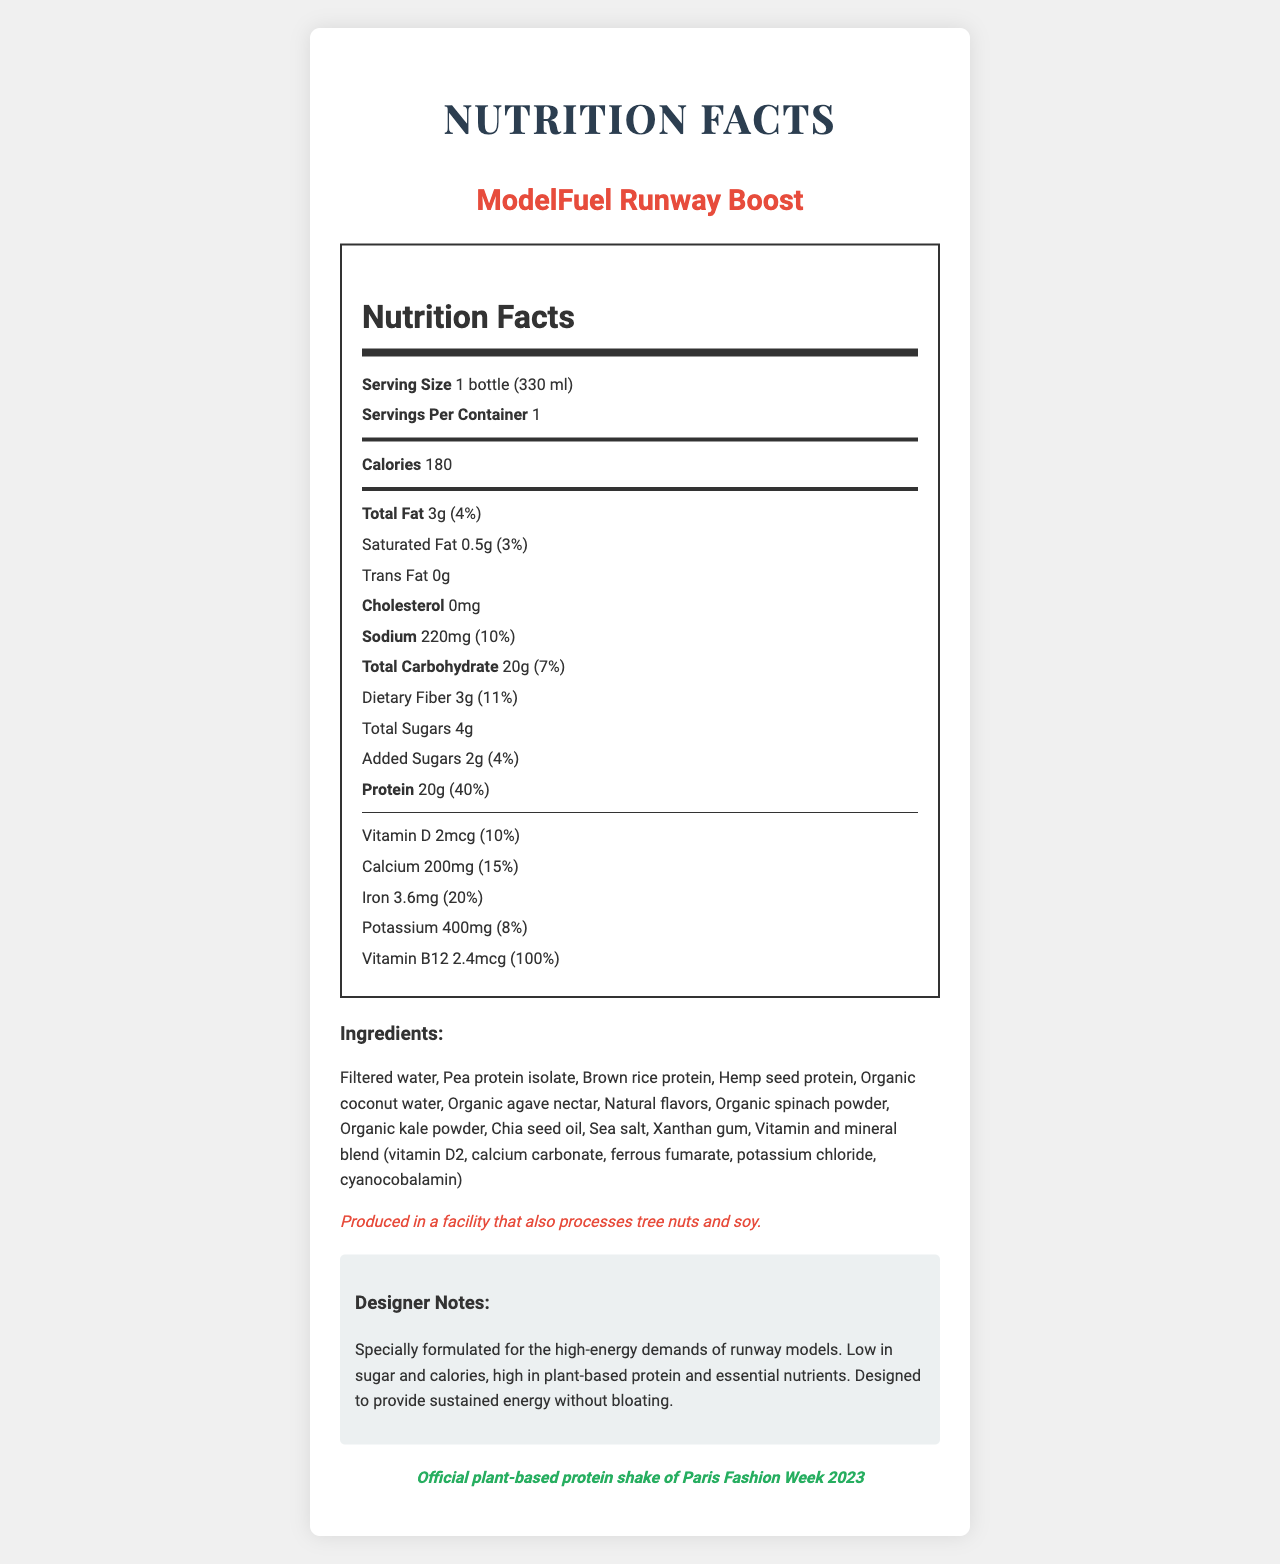how many calories are in one serving? The document lists the calorie content as 180 for one bottle, which is one serving.
Answer: 180 what is the serving size for ModelFuel Runway Boost? The document specifies that the serving size is 1 bottle, which equals 330 ml.
Answer: 1 bottle (330 ml) how much protein does one serving contain? The nutrition facts on the document indicate that one serving contains 20 grams of protein.
Answer: 20g what percentage of the daily value of calcium does one serving provide? The document shows that the calcium content provides 15% of the daily value per serving.
Answer: 15% what is the amount of sodium in one serving? The document lists 220mg as the sodium content for one serving.
Answer: 220mg what are the total sugars in one serving? The nutritional information in the document indicates that there are 4 grams of total sugars in one serving.
Answer: 4g what is the total fat content and daily value percentage? A. 2g (3%) B. 3g (4%) C. 5g (6%) D. 4g (5%) The document indicates that the total fat in one serving is 3 grams, which is 4% of the daily value.
Answer: B how much vitamin B12 is in one serving? A. 1.2mcg B. 2.4mcg C. 3.6mcg D. 4.8mcg The document states that one serving contains 2.4 micrograms of vitamin B12.
Answer: B does this product contain any cholesterol? The nutritional information lists 0mg of cholesterol, so the product does not contain any cholesterol.
Answer: No does the product have any endorsements? The product is endorsed as the official plant-based protein shake of Paris Fashion Week 2023.
Answer: Yes what are the main ingredients in ModelFuel Runway Boost? These ingredients are all listed in the document under the ingredients section.
Answer: Filtered water, Pea protein isolate, Brown rice protein, Hemp seed protein, Organic coconut water, Organic agave nectar, Natural flavors, Organic spinach powder, Organic kale powder, Chia seed oil, Sea salt, Xanthan gum, Vitamin and mineral blend how much trans fat does the product contain? The document clearly states that the trans fat content is 0 grams.
Answer: 0g what is the total carbohydrate content in one serving? According to the nutritional information, the total carbohydrate content is 20 grams per serving.
Answer: 20g which vitamins and minerals are specified in the nutritional information? The document lists these specific vitamins and minerals along with their amounts and daily values.
Answer: Vitamin D, Calcium, Iron, Potassium, Vitamin B12 is the product suitable for those with tree nut allergies? The document mentions that the product is produced in a facility that also processes tree nuts and soy, but it does not specify whether the product itself contains tree nuts.
Answer: Cannot be determined could you summarize the nutritional benefits of ModelFuel Runway Boost? The document contains detailed nutritional information and explains that the product is suitable for fashion models needing sustained energy.
Answer: ModelFuel Runway Boost is a plant-based protein shake with 180 calories per serving. It is low in sugar and fat, provides 20g of protein, and includes essential vitamins and minerals such as vitamin D, calcium, iron, potassium, and vitamin B12. The product is designed to meet the high-energy demands of runway models while being low in bloat-inducing ingredients. what is the fat content per serving? The document provides detailed fat contents for total, saturated, and trans fats in the nutrition facts section.
Answer: Total Fat: 3g, Saturated Fat: 0.5g, Trans Fat: 0g 